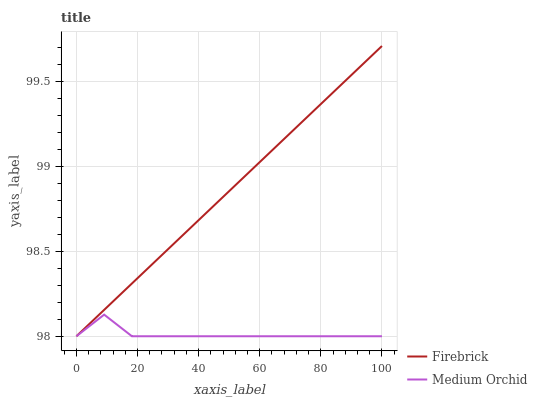Does Medium Orchid have the minimum area under the curve?
Answer yes or no. Yes. Does Firebrick have the maximum area under the curve?
Answer yes or no. Yes. Does Medium Orchid have the maximum area under the curve?
Answer yes or no. No. Is Firebrick the smoothest?
Answer yes or no. Yes. Is Medium Orchid the roughest?
Answer yes or no. Yes. Is Medium Orchid the smoothest?
Answer yes or no. No. Does Firebrick have the lowest value?
Answer yes or no. Yes. Does Firebrick have the highest value?
Answer yes or no. Yes. Does Medium Orchid have the highest value?
Answer yes or no. No. Does Firebrick intersect Medium Orchid?
Answer yes or no. Yes. Is Firebrick less than Medium Orchid?
Answer yes or no. No. Is Firebrick greater than Medium Orchid?
Answer yes or no. No. 